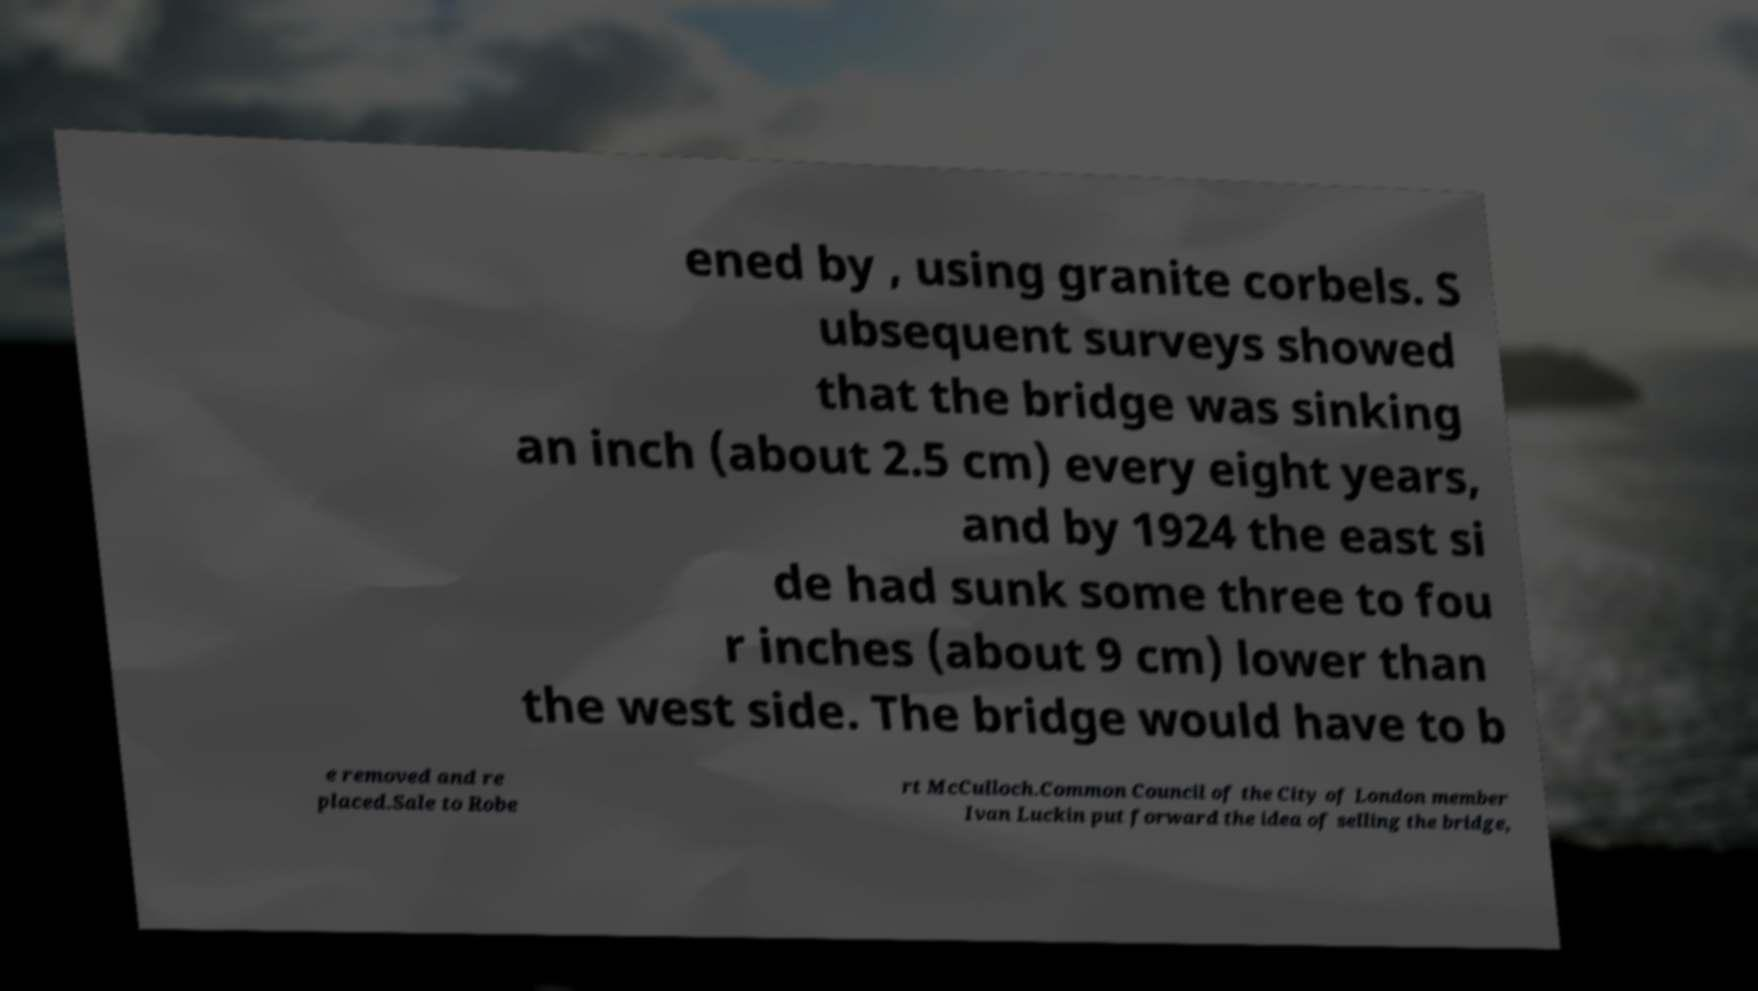I need the written content from this picture converted into text. Can you do that? ened by , using granite corbels. S ubsequent surveys showed that the bridge was sinking an inch (about 2.5 cm) every eight years, and by 1924 the east si de had sunk some three to fou r inches (about 9 cm) lower than the west side. The bridge would have to b e removed and re placed.Sale to Robe rt McCulloch.Common Council of the City of London member Ivan Luckin put forward the idea of selling the bridge, 